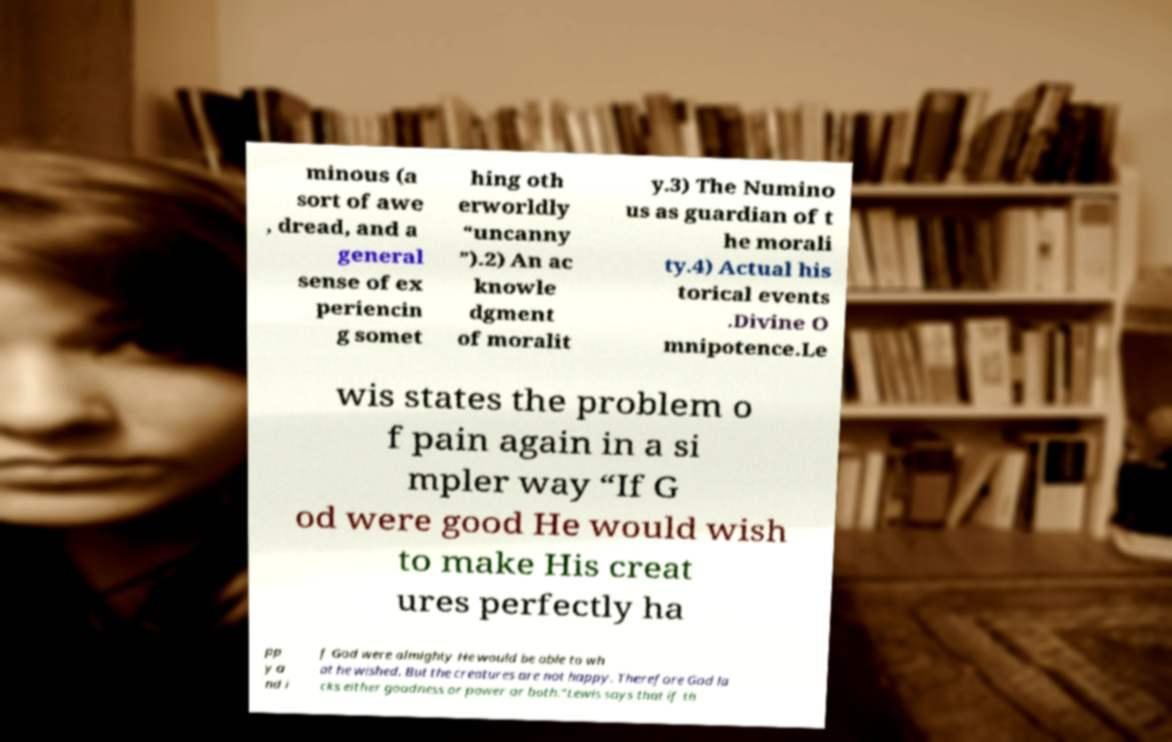What messages or text are displayed in this image? I need them in a readable, typed format. minous (a sort of awe , dread, and a general sense of ex periencin g somet hing oth erworldly “uncanny ”).2) An ac knowle dgment of moralit y.3) The Numino us as guardian of t he morali ty.4) Actual his torical events .Divine O mnipotence.Le wis states the problem o f pain again in a si mpler way “If G od were good He would wish to make His creat ures perfectly ha pp y a nd i f God were almighty He would be able to wh at he wished. But the creatures are not happy. Therefore God la cks either goodness or power or both.”Lewis says that if th 